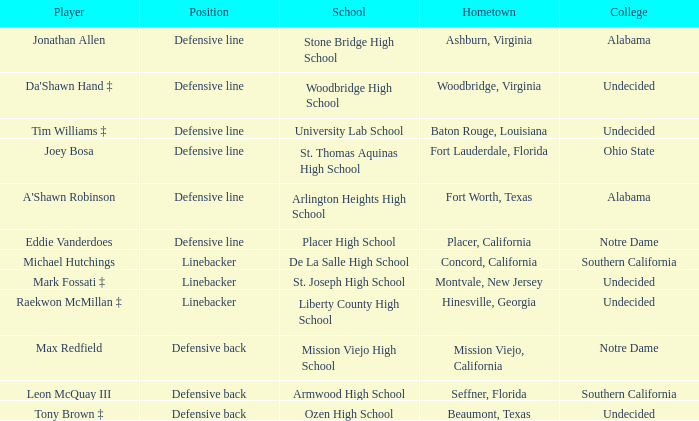What is the rank of the sportsperson from beaumont, texas? Defensive back. 